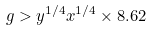Convert formula to latex. <formula><loc_0><loc_0><loc_500><loc_500>g > y ^ { 1 / 4 } x ^ { 1 / 4 } \times 8 . 6 2</formula> 